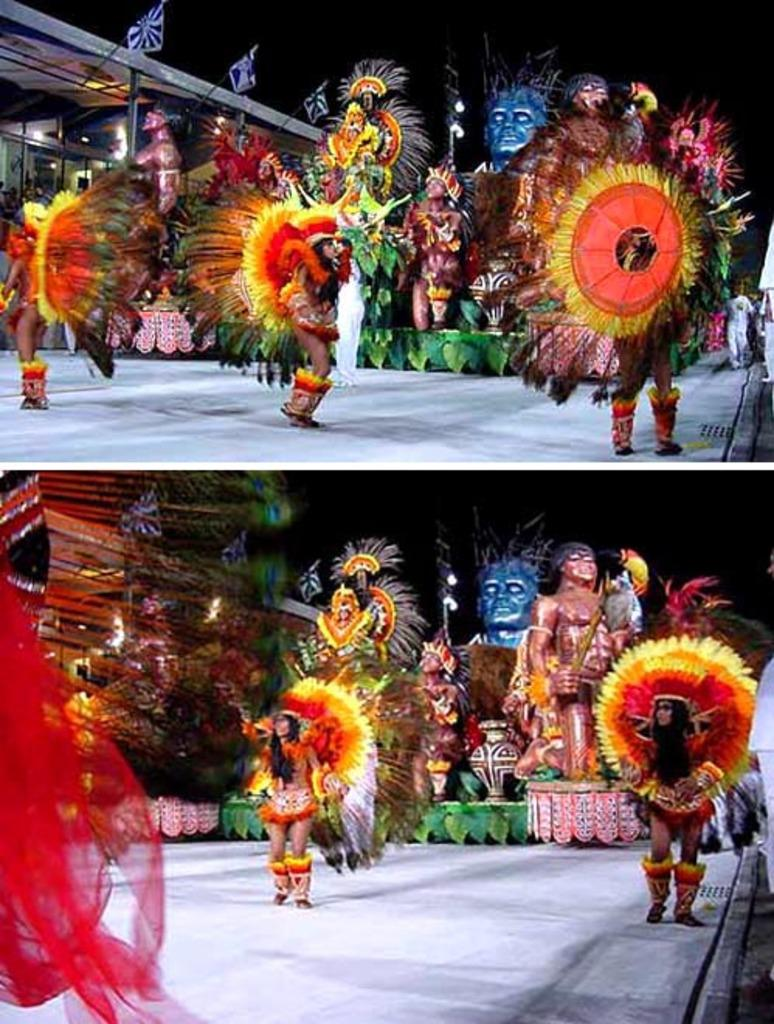What type of artwork is the image? The image is a collage. What activities are the persons in the image engaged in? The persons in the image are performing. What non-living object can be seen in the image? There is a statue in the image. What type of structure is present in the image? There is a building in the image. Can you see any birds wearing masks in the image? There are no birds or masks present in the image. How many persons are jumping in the image? There is no information about anyone jumping in the image. 